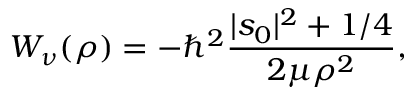<formula> <loc_0><loc_0><loc_500><loc_500>W _ { \nu } ( \rho ) = - \hbar { ^ } { 2 } \frac { | s _ { 0 } | ^ { 2 } + 1 / 4 } { 2 \mu \rho ^ { 2 } } ,</formula> 